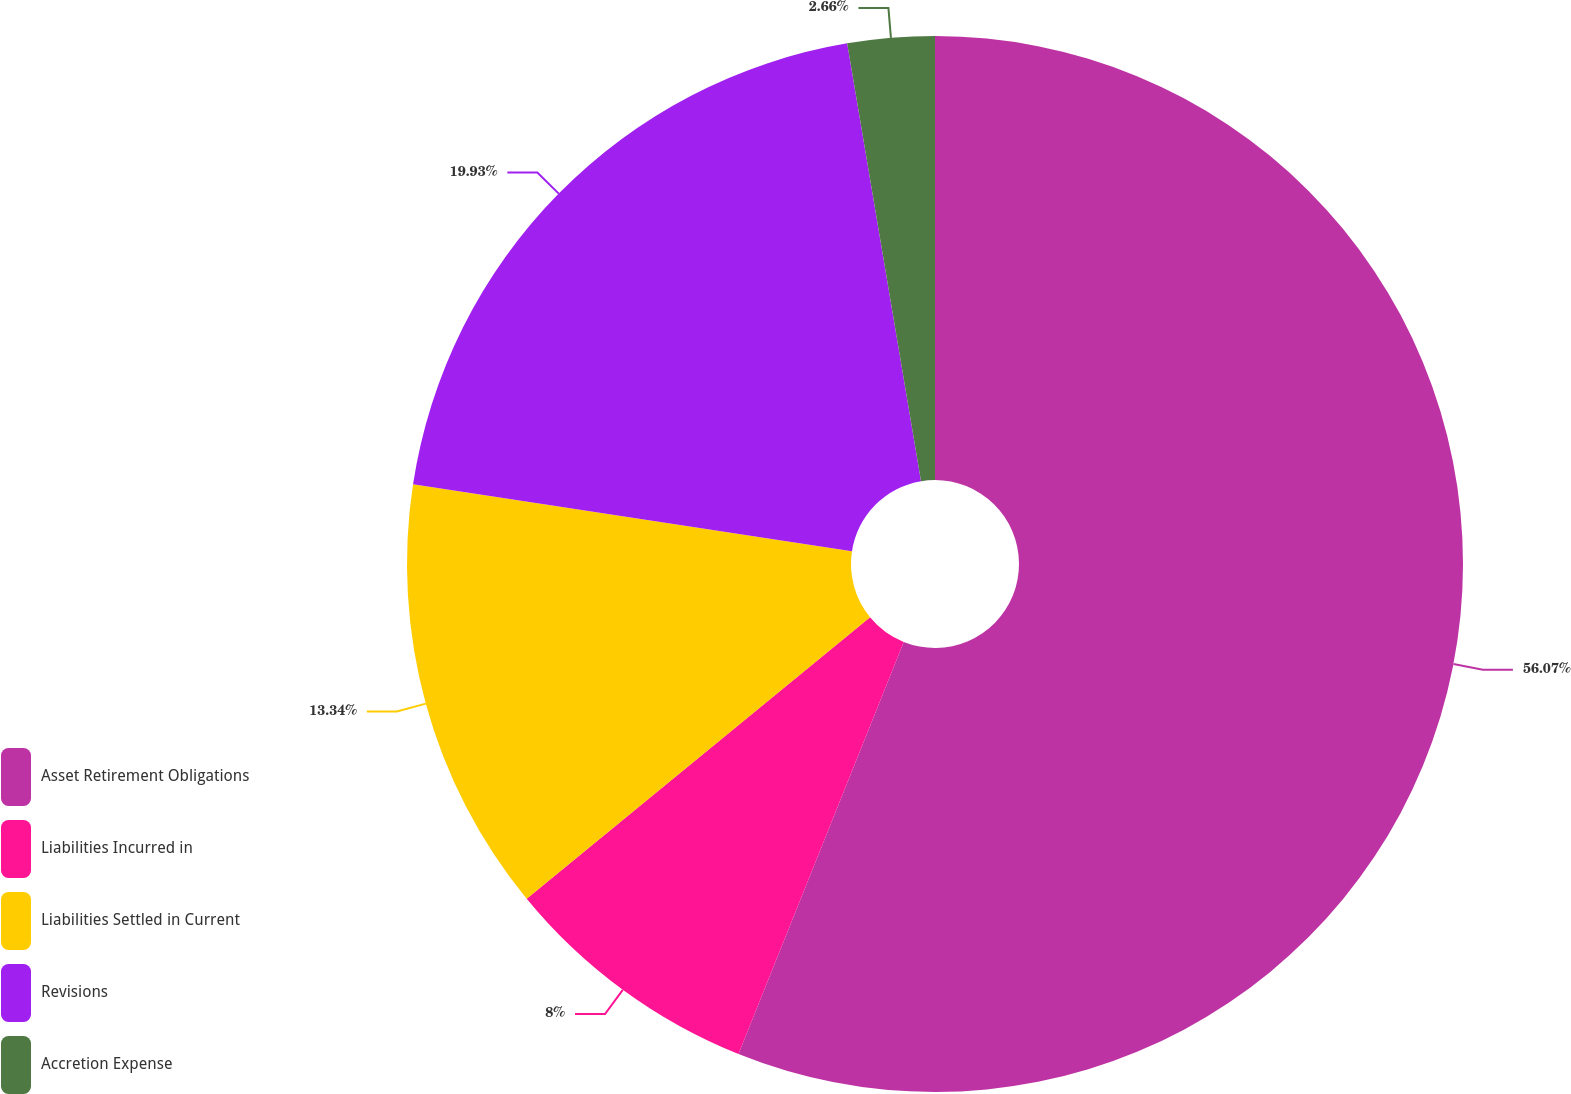Convert chart. <chart><loc_0><loc_0><loc_500><loc_500><pie_chart><fcel>Asset Retirement Obligations<fcel>Liabilities Incurred in<fcel>Liabilities Settled in Current<fcel>Revisions<fcel>Accretion Expense<nl><fcel>56.07%<fcel>8.0%<fcel>13.34%<fcel>19.93%<fcel>2.66%<nl></chart> 